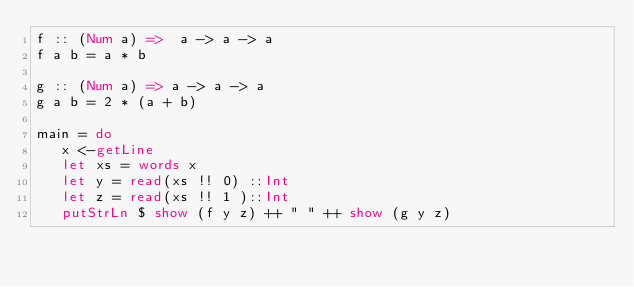Convert code to text. <code><loc_0><loc_0><loc_500><loc_500><_Haskell_>f :: (Num a) =>  a -> a -> a 
f a b = a * b

g :: (Num a) => a -> a -> a
g a b = 2 * (a + b)

main = do 
   x <-getLine 
   let xs = words x 
   let y = read(xs !! 0) ::Int
   let z = read(xs !! 1 )::Int
   putStrLn $ show (f y z) ++ " " ++ show (g y z)
   </code> 